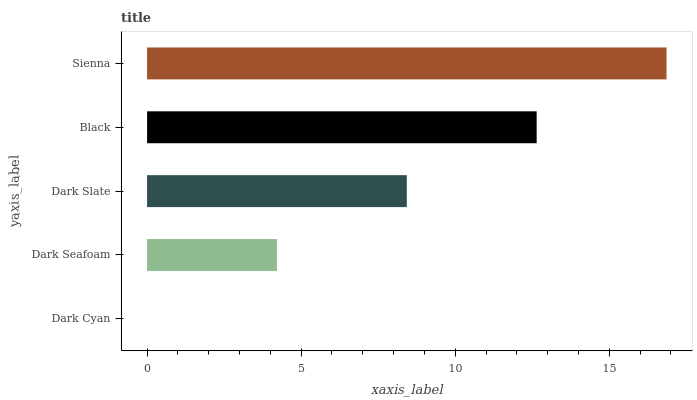Is Dark Cyan the minimum?
Answer yes or no. Yes. Is Sienna the maximum?
Answer yes or no. Yes. Is Dark Seafoam the minimum?
Answer yes or no. No. Is Dark Seafoam the maximum?
Answer yes or no. No. Is Dark Seafoam greater than Dark Cyan?
Answer yes or no. Yes. Is Dark Cyan less than Dark Seafoam?
Answer yes or no. Yes. Is Dark Cyan greater than Dark Seafoam?
Answer yes or no. No. Is Dark Seafoam less than Dark Cyan?
Answer yes or no. No. Is Dark Slate the high median?
Answer yes or no. Yes. Is Dark Slate the low median?
Answer yes or no. Yes. Is Black the high median?
Answer yes or no. No. Is Dark Seafoam the low median?
Answer yes or no. No. 